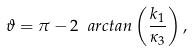Convert formula to latex. <formula><loc_0><loc_0><loc_500><loc_500>\vartheta = \pi - 2 \ a r c t a n \left ( \frac { k _ { 1 } } { \kappa _ { 3 } } \right ) ,</formula> 